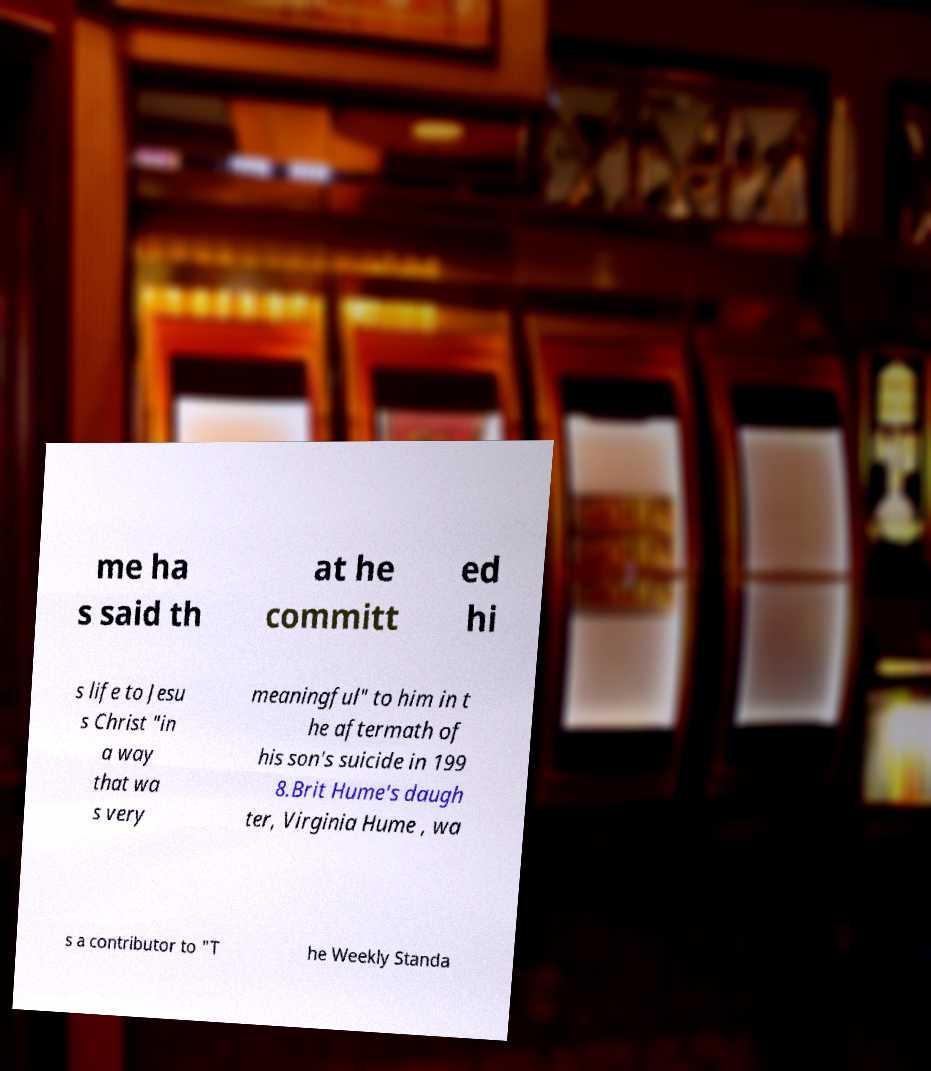Can you read and provide the text displayed in the image?This photo seems to have some interesting text. Can you extract and type it out for me? me ha s said th at he committ ed hi s life to Jesu s Christ "in a way that wa s very meaningful" to him in t he aftermath of his son's suicide in 199 8.Brit Hume's daugh ter, Virginia Hume , wa s a contributor to "T he Weekly Standa 